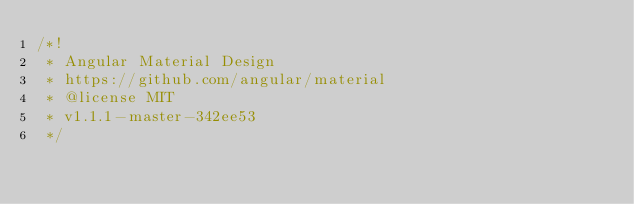Convert code to text. <code><loc_0><loc_0><loc_500><loc_500><_JavaScript_>/*!
 * Angular Material Design
 * https://github.com/angular/material
 * @license MIT
 * v1.1.1-master-342ee53
 */</code> 